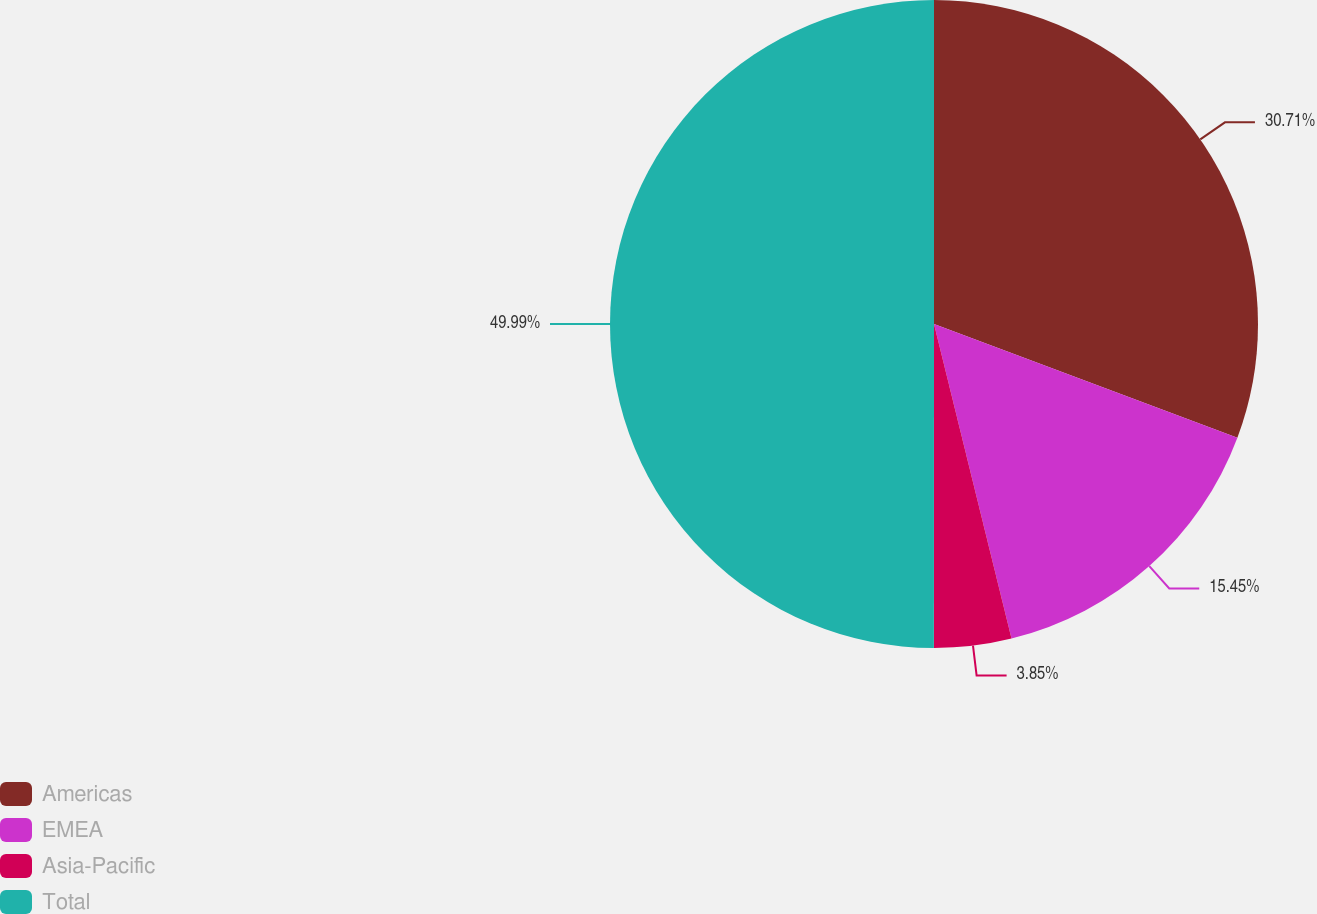Convert chart. <chart><loc_0><loc_0><loc_500><loc_500><pie_chart><fcel>Americas<fcel>EMEA<fcel>Asia-Pacific<fcel>Total<nl><fcel>30.71%<fcel>15.45%<fcel>3.85%<fcel>50.0%<nl></chart> 